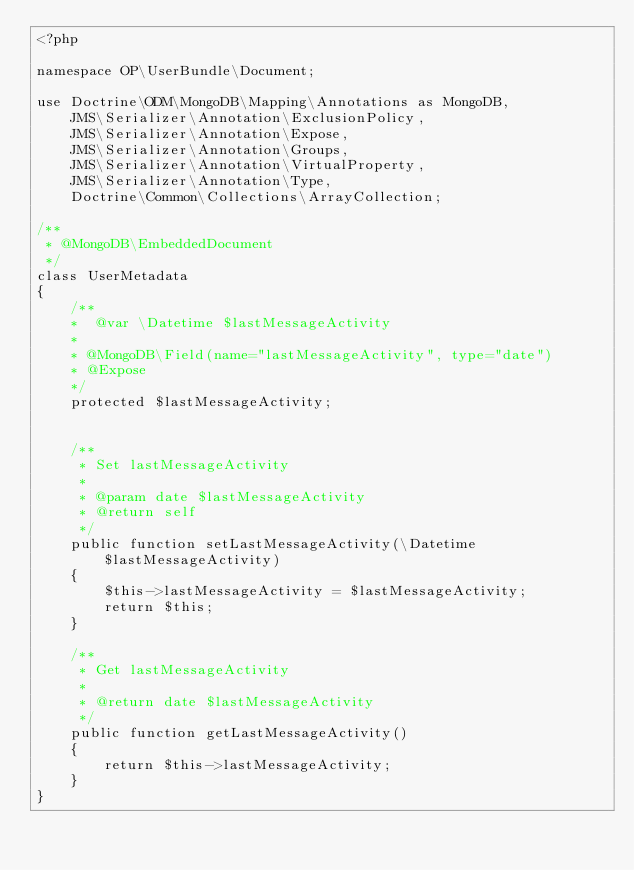Convert code to text. <code><loc_0><loc_0><loc_500><loc_500><_PHP_><?php

namespace OP\UserBundle\Document;

use Doctrine\ODM\MongoDB\Mapping\Annotations as MongoDB,
    JMS\Serializer\Annotation\ExclusionPolicy,
    JMS\Serializer\Annotation\Expose,
    JMS\Serializer\Annotation\Groups,
    JMS\Serializer\Annotation\VirtualProperty,
    JMS\Serializer\Annotation\Type,
    Doctrine\Common\Collections\ArrayCollection;

/**
 * @MongoDB\EmbeddedDocument
 */
class UserMetadata
{
    /**
    *  @var \Datetime $lastMessageActivity
    *
    * @MongoDB\Field(name="lastMessageActivity", type="date")
    * @Expose
    */
    protected $lastMessageActivity;


    /**
     * Set lastMessageActivity
     *
     * @param date $lastMessageActivity
     * @return self
     */
    public function setLastMessageActivity(\Datetime $lastMessageActivity)
    {
        $this->lastMessageActivity = $lastMessageActivity;
        return $this;
    }

    /**
     * Get lastMessageActivity
     *
     * @return date $lastMessageActivity
     */
    public function getLastMessageActivity()
    {
        return $this->lastMessageActivity;
    }
}
</code> 